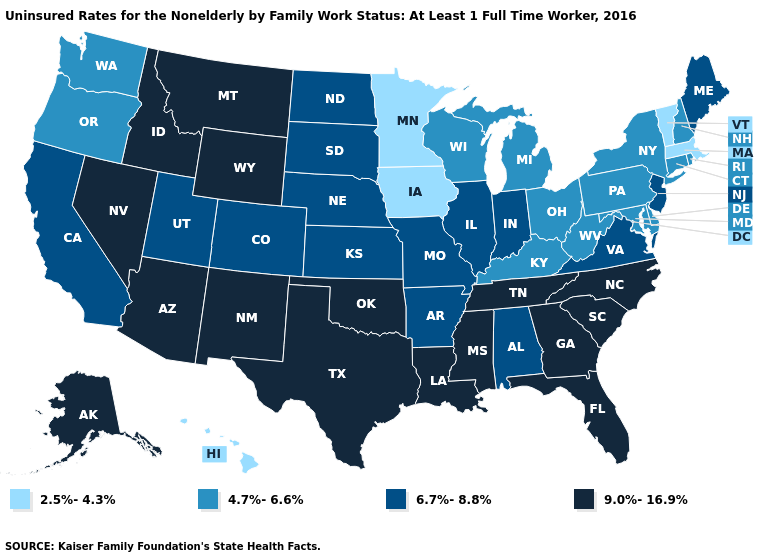Name the states that have a value in the range 9.0%-16.9%?
Quick response, please. Alaska, Arizona, Florida, Georgia, Idaho, Louisiana, Mississippi, Montana, Nevada, New Mexico, North Carolina, Oklahoma, South Carolina, Tennessee, Texas, Wyoming. What is the value of Colorado?
Quick response, please. 6.7%-8.8%. What is the lowest value in the USA?
Quick response, please. 2.5%-4.3%. Name the states that have a value in the range 9.0%-16.9%?
Short answer required. Alaska, Arizona, Florida, Georgia, Idaho, Louisiana, Mississippi, Montana, Nevada, New Mexico, North Carolina, Oklahoma, South Carolina, Tennessee, Texas, Wyoming. What is the value of Louisiana?
Short answer required. 9.0%-16.9%. Does Connecticut have the highest value in the Northeast?
Be succinct. No. How many symbols are there in the legend?
Keep it brief. 4. Name the states that have a value in the range 2.5%-4.3%?
Answer briefly. Hawaii, Iowa, Massachusetts, Minnesota, Vermont. What is the highest value in states that border South Dakota?
Quick response, please. 9.0%-16.9%. What is the value of Georgia?
Give a very brief answer. 9.0%-16.9%. What is the highest value in the West ?
Be succinct. 9.0%-16.9%. Does Washington have the highest value in the USA?
Be succinct. No. Does North Dakota have the lowest value in the MidWest?
Concise answer only. No. Name the states that have a value in the range 4.7%-6.6%?
Answer briefly. Connecticut, Delaware, Kentucky, Maryland, Michigan, New Hampshire, New York, Ohio, Oregon, Pennsylvania, Rhode Island, Washington, West Virginia, Wisconsin. Does Iowa have the highest value in the MidWest?
Be succinct. No. 